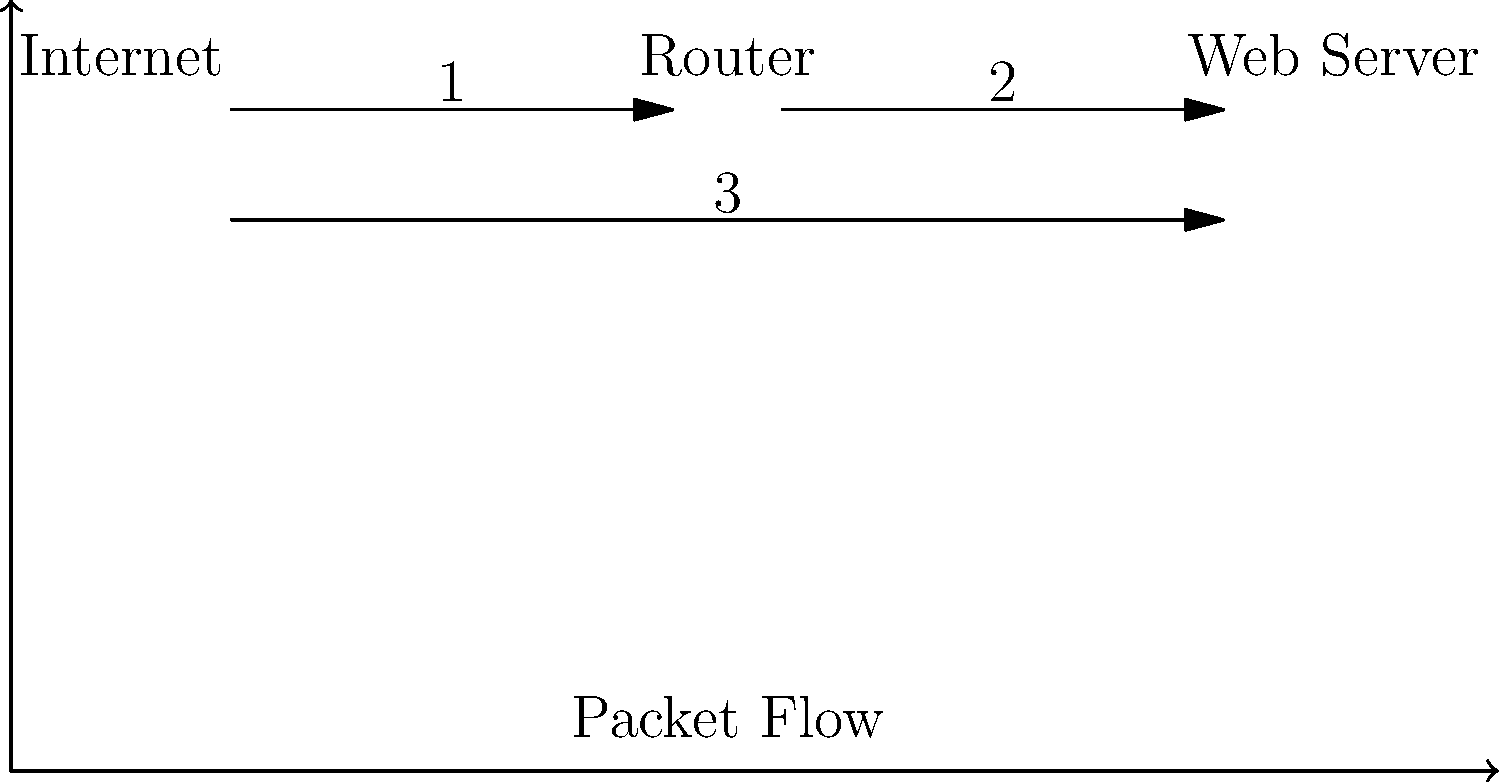In the given iptables packet flow diagram for a Ubuntu server, which iptables chain should be configured to allow incoming HTTP traffic (port 80) from the Internet to reach the Web Server, assuming a default policy of DROP for all chains? To understand the correct iptables chain to configure, let's analyze the packet flow:

1. The packet originates from the Internet (left side of the diagram).
2. It passes through the Router (middle of the diagram).
3. Finally, it reaches the Web Server (right side of the diagram).

In iptables, there are three main chains for the filter table:
- INPUT: for packets destined to the local system
- FORWARD: for packets routed through the system
- OUTPUT: for locally-generated packets

Given that we want to allow incoming HTTP traffic from the Internet to reach the Web Server, we need to focus on the FORWARD chain. Here's why:

1. The packet is not destined for the local system (Router), so INPUT is not appropriate.
2. The packet is being routed through the system from the Internet to the Web Server, which is exactly what the FORWARD chain handles.
3. The packet is not locally generated, so OUTPUT is not relevant.

To allow this traffic, we would need to add a rule to the FORWARD chain that accepts packets with the following characteristics:
- Protocol: TCP
- Destination port: 80 (HTTP)
- State: NEW, ESTABLISHED

The iptables command to add this rule would be:

```
iptables -A FORWARD -p tcp --dport 80 -m state --state NEW,ESTABLISHED -j ACCEPT
```

This rule should be placed before any DROP rules in the FORWARD chain to ensure it takes effect.
Answer: FORWARD chain 